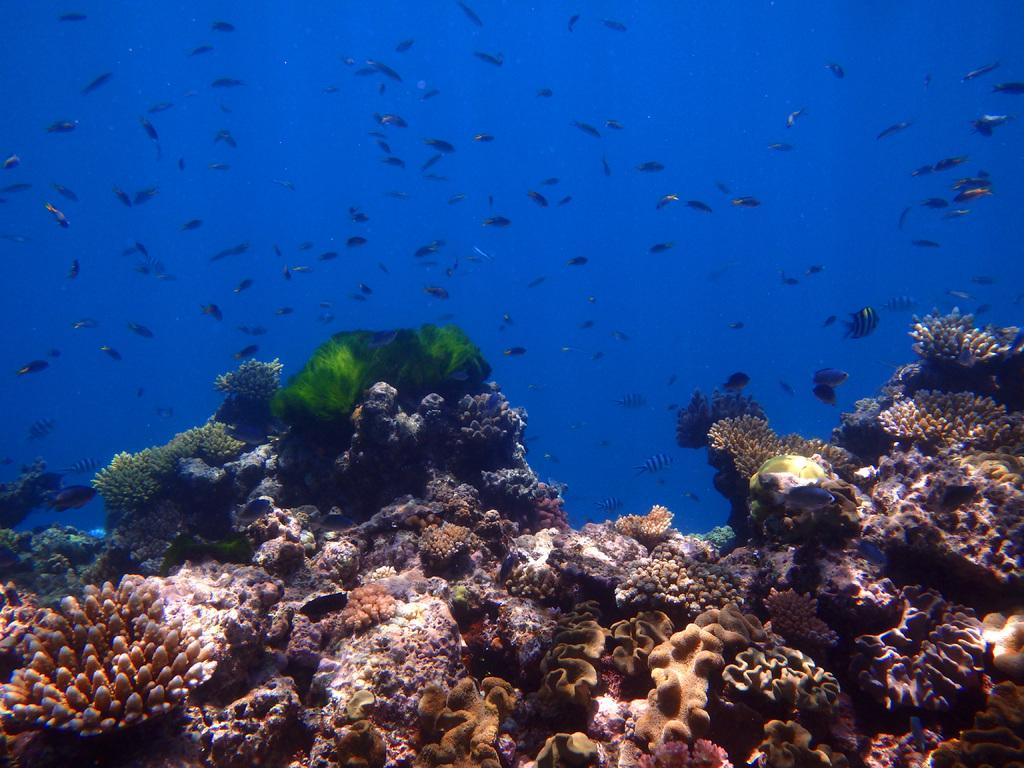What is the setting of the image? The image is taken underwater. What types of marine life can be seen in the image? There are fishes in the image. What is visible at the bottom of the image? There are water plants at the bottom of the image. What type of map can be seen on the back of the fish in the image? There is no map visible on the back of any fish in the image. 